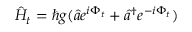<formula> <loc_0><loc_0><loc_500><loc_500>\hat { H } _ { t } = \hbar { g } ( \hat { a } e ^ { i \Phi _ { t } } + \hat { a } ^ { \dagger } e ^ { - i \Phi _ { t } } )</formula> 